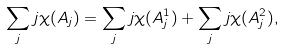Convert formula to latex. <formula><loc_0><loc_0><loc_500><loc_500>\sum _ { j } j \chi ( A _ { j } ) = \sum _ { j } j \chi ( A _ { j } ^ { 1 } ) + \sum _ { j } j \chi ( A _ { j } ^ { 2 } ) ,</formula> 